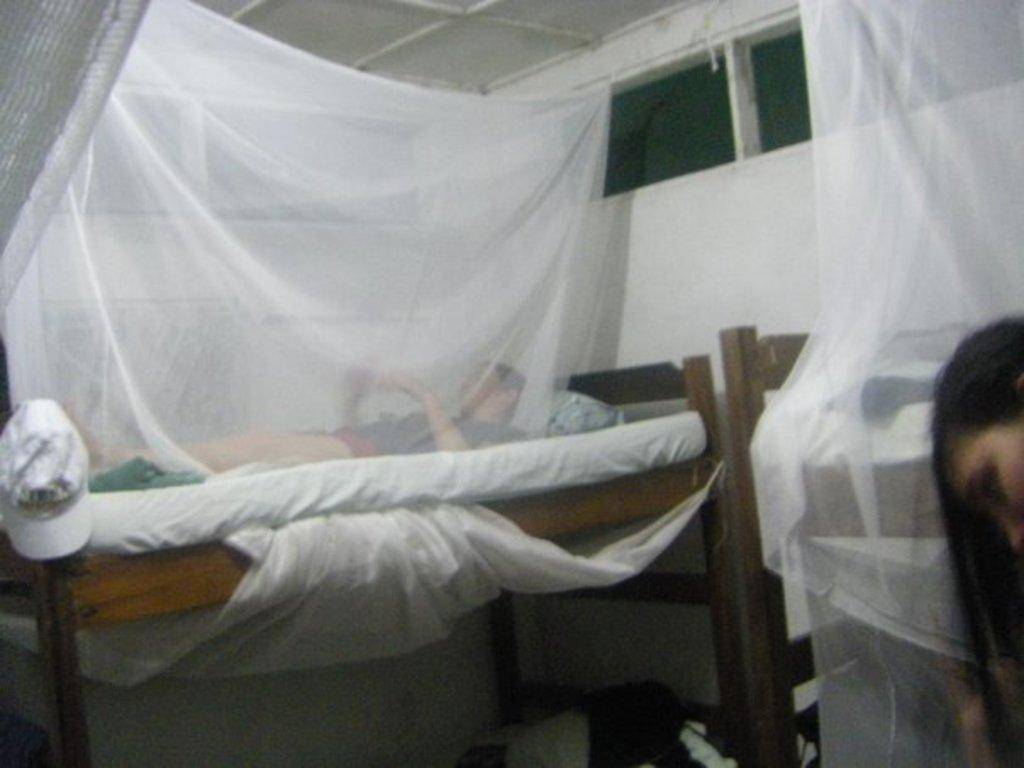What piece of furniture is present in the image? There is a bed in the image. What is the man in the image doing? A man is lying on the bed. Is there a lamp on the bedside table in the image? There is no mention of a lamp or a bedside table in the provided facts, so we cannot determine if there is a lamp present in the image. 